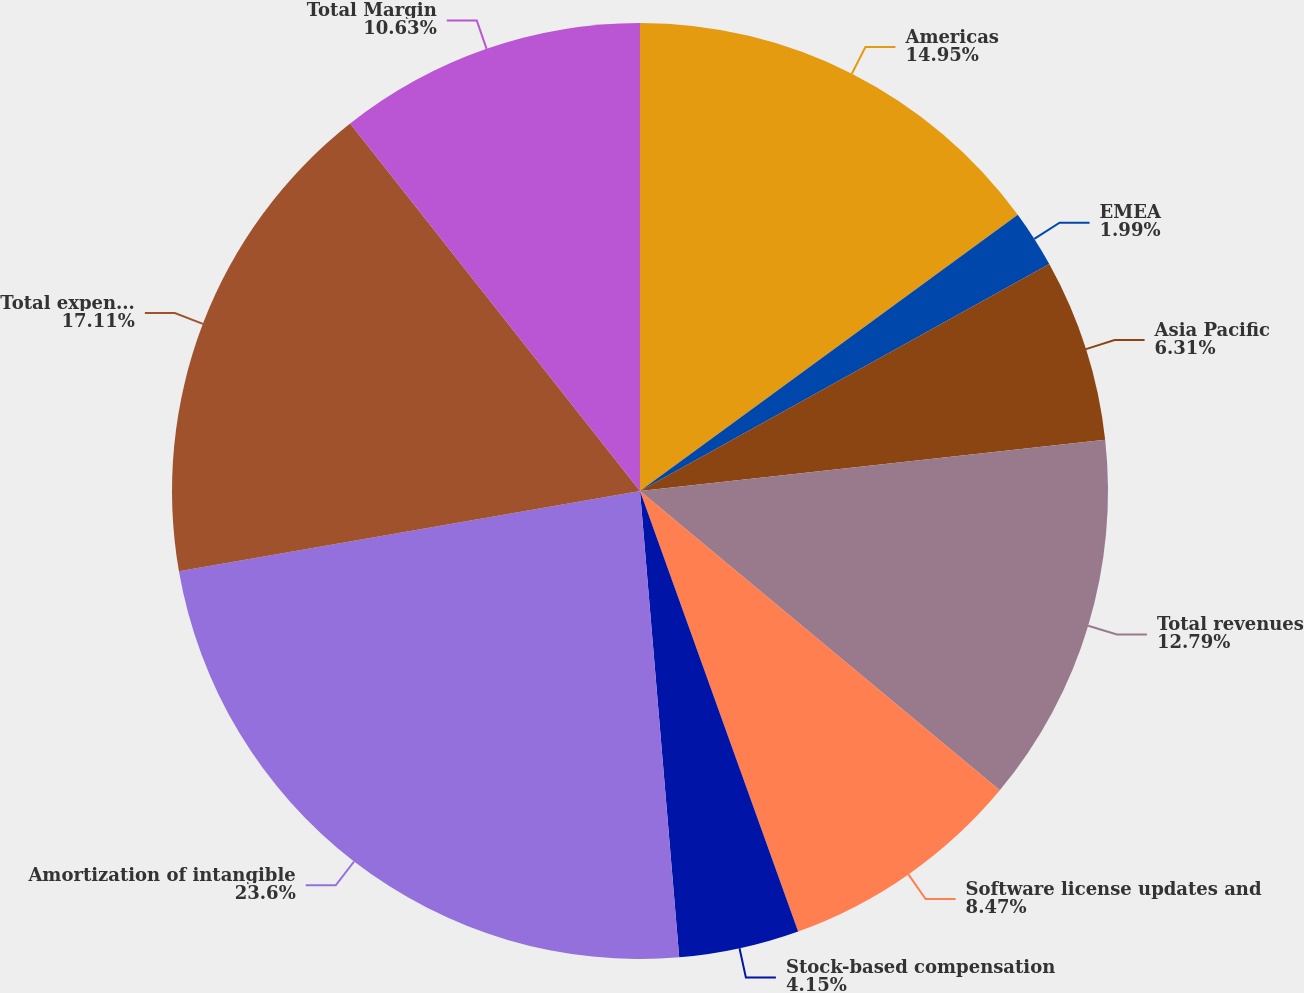Convert chart to OTSL. <chart><loc_0><loc_0><loc_500><loc_500><pie_chart><fcel>Americas<fcel>EMEA<fcel>Asia Pacific<fcel>Total revenues<fcel>Software license updates and<fcel>Stock-based compensation<fcel>Amortization of intangible<fcel>Total expenses<fcel>Total Margin<nl><fcel>14.95%<fcel>1.99%<fcel>6.31%<fcel>12.79%<fcel>8.47%<fcel>4.15%<fcel>23.59%<fcel>17.11%<fcel>10.63%<nl></chart> 